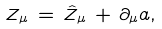<formula> <loc_0><loc_0><loc_500><loc_500>Z _ { \mu } \, = \, \hat { Z } _ { \mu } \, + \, \partial _ { \mu } a ,</formula> 